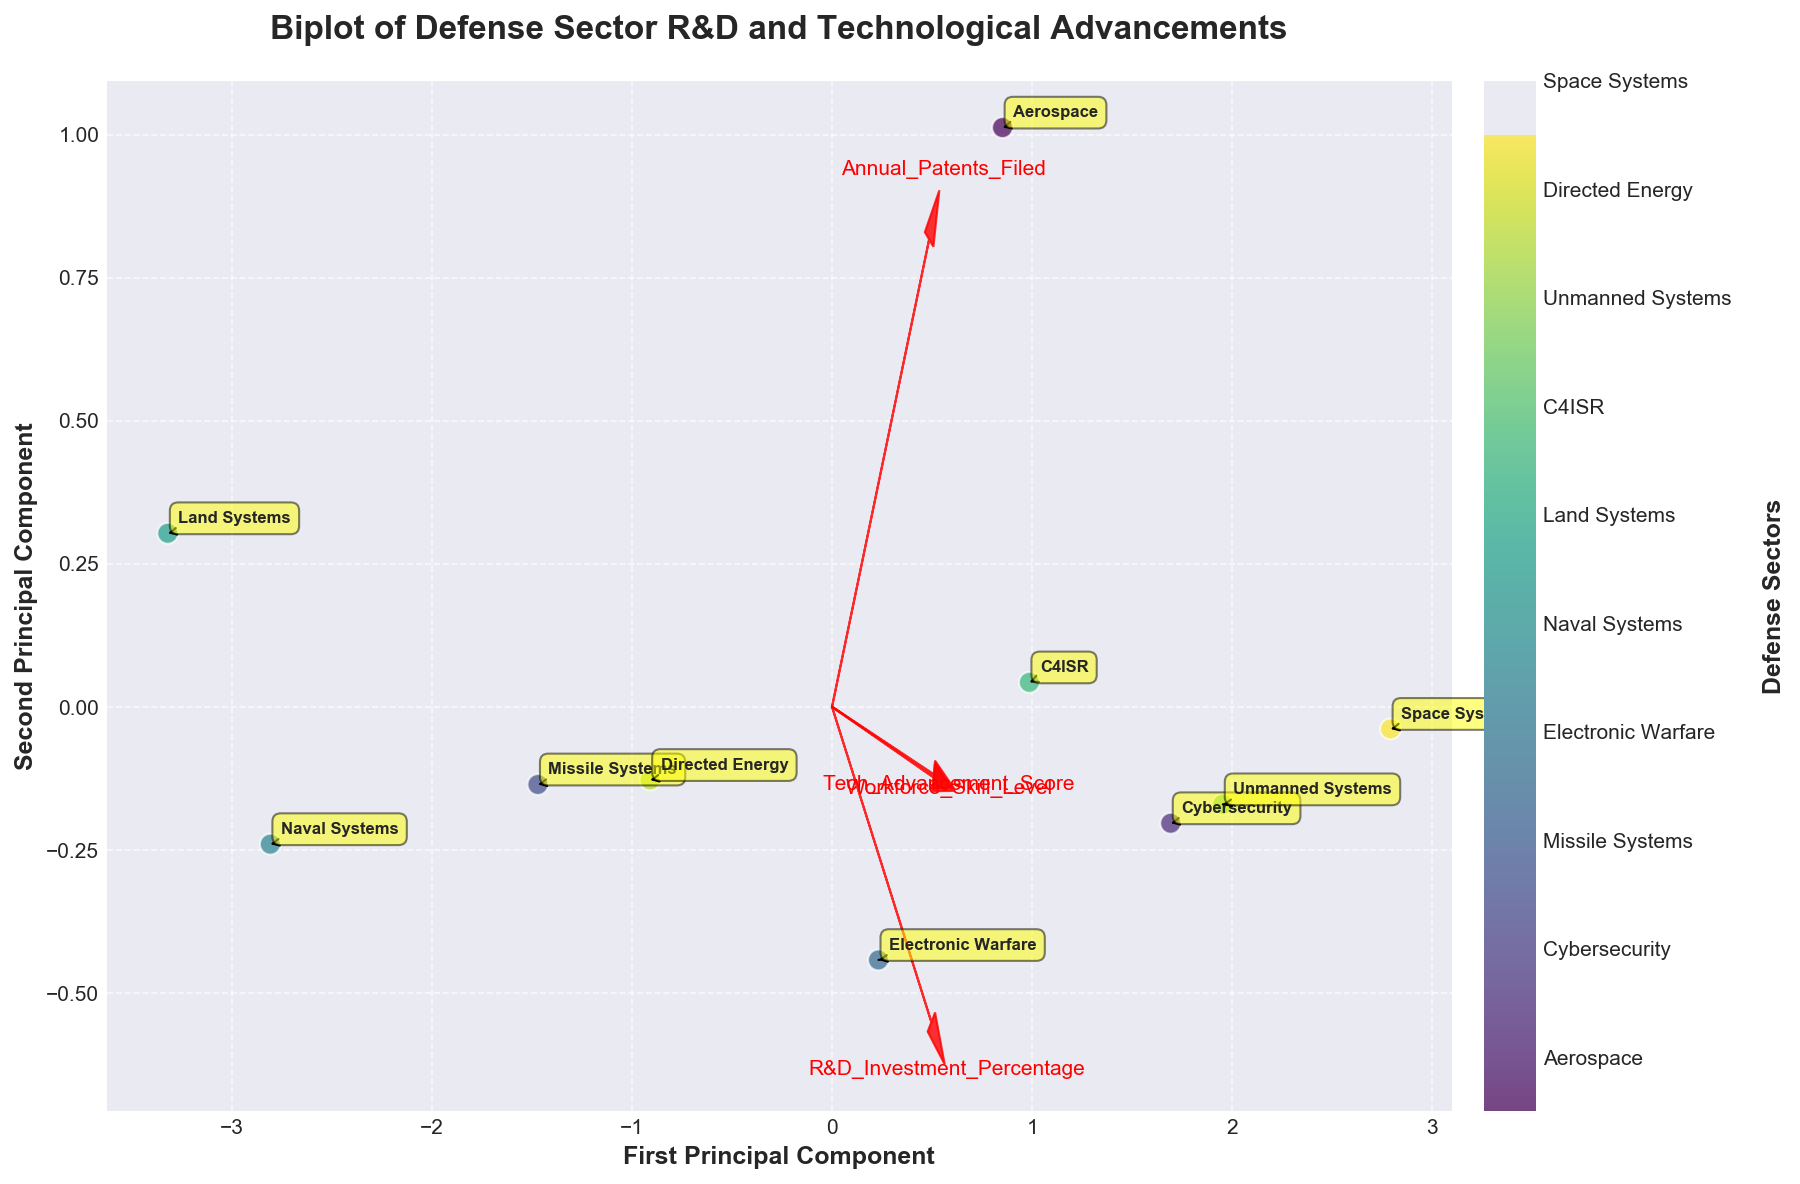What is the title of the biplot? The title is displayed at the top of the figure and typically summarizes the key theme or concept of the graph.
Answer: Biplot of Defense Sector R&D and Technological Advancements How many data points are there in total? The number of data points corresponds to how many sectors are represented in the biplot, each shown as a dot in the plot. Counting these dots provides the answer.
Answer: 10 Which sector has the highest value on the first principal component? By looking at the scatter points along the x-axis (first principal component), identify the point positioned furthest to the right which will represent the sector with the highest value.
Answer: Space Systems How do the directions of the arrows for 'R&D Investment Percentage' and 'Tech Advancement Score' compare? Observe the arrows drawn from the origin. Comparing their angles and directions will highlight if they point in similar, opposite, or different directions.
Answer: They point in similar directions Which sectors appear closest to each other in the biplot? Identify the pairs of points that are geographically closest to each other on the plot. This indicates that these sectors have similar scores on the principal components.
Answer: Cybersecurity and Unmanned Systems Which sector has the lowest value on the second principal component? By examining the scatter points along the y-axis (second principal component), find the point positioned lowest which represents the sector with the smallest value.
Answer: Land Systems Assess the relationship between 'Workforce Skill Level' and the first principal component. Is it generally positive, negative, or neutral? Look at the direction of the arrow representing 'Workforce Skill Level' relative to the x-axis. The alignment suggests the nature of the relationship. If they point in the same direction, it is positive; opposite, it is negative.
Answer: Positive Which two features have the most similar influence on the first principal component based on the direction of the feature vectors? Examine the arrows and see which two are most closely aligned in terms of direction and length relative to the x-axis; these represent the features with the most similar influence.
Answer: Tech Advancement Score and Workforce Skill Level Compare 'Annual Patents Filed' and 'R&D Investment Percentage'. Which has a greater influence on the second principal component? Look at the length of the arrows for both features along the y-axis direction (second principal component). The longer arrow indicates the feature with greater influence.
Answer: R&D Investment Percentage 